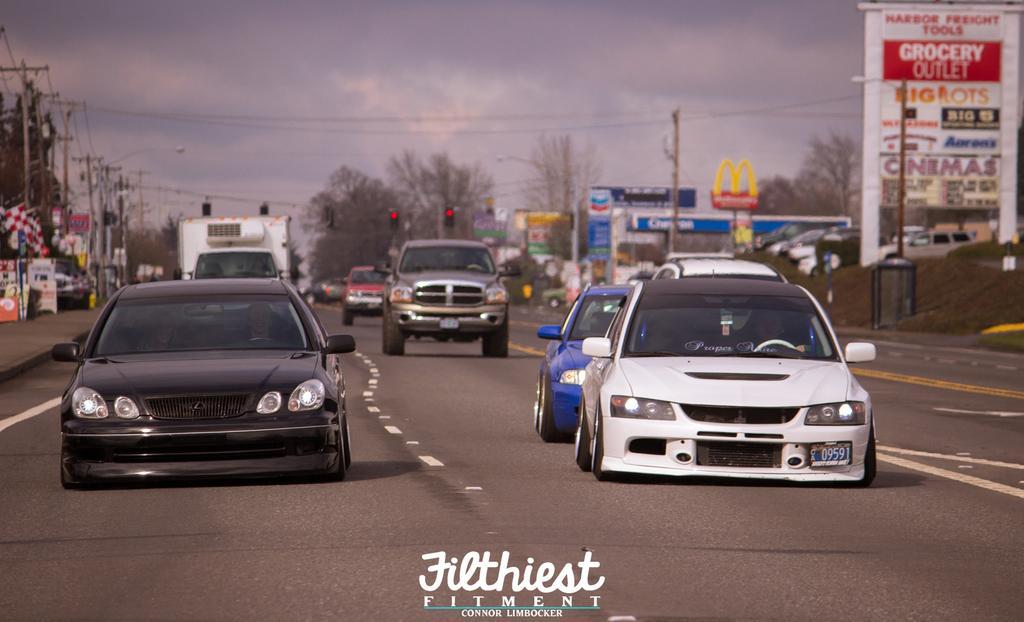<image>
Write a terse but informative summary of the picture. the words grocery outlet that are on a sign 